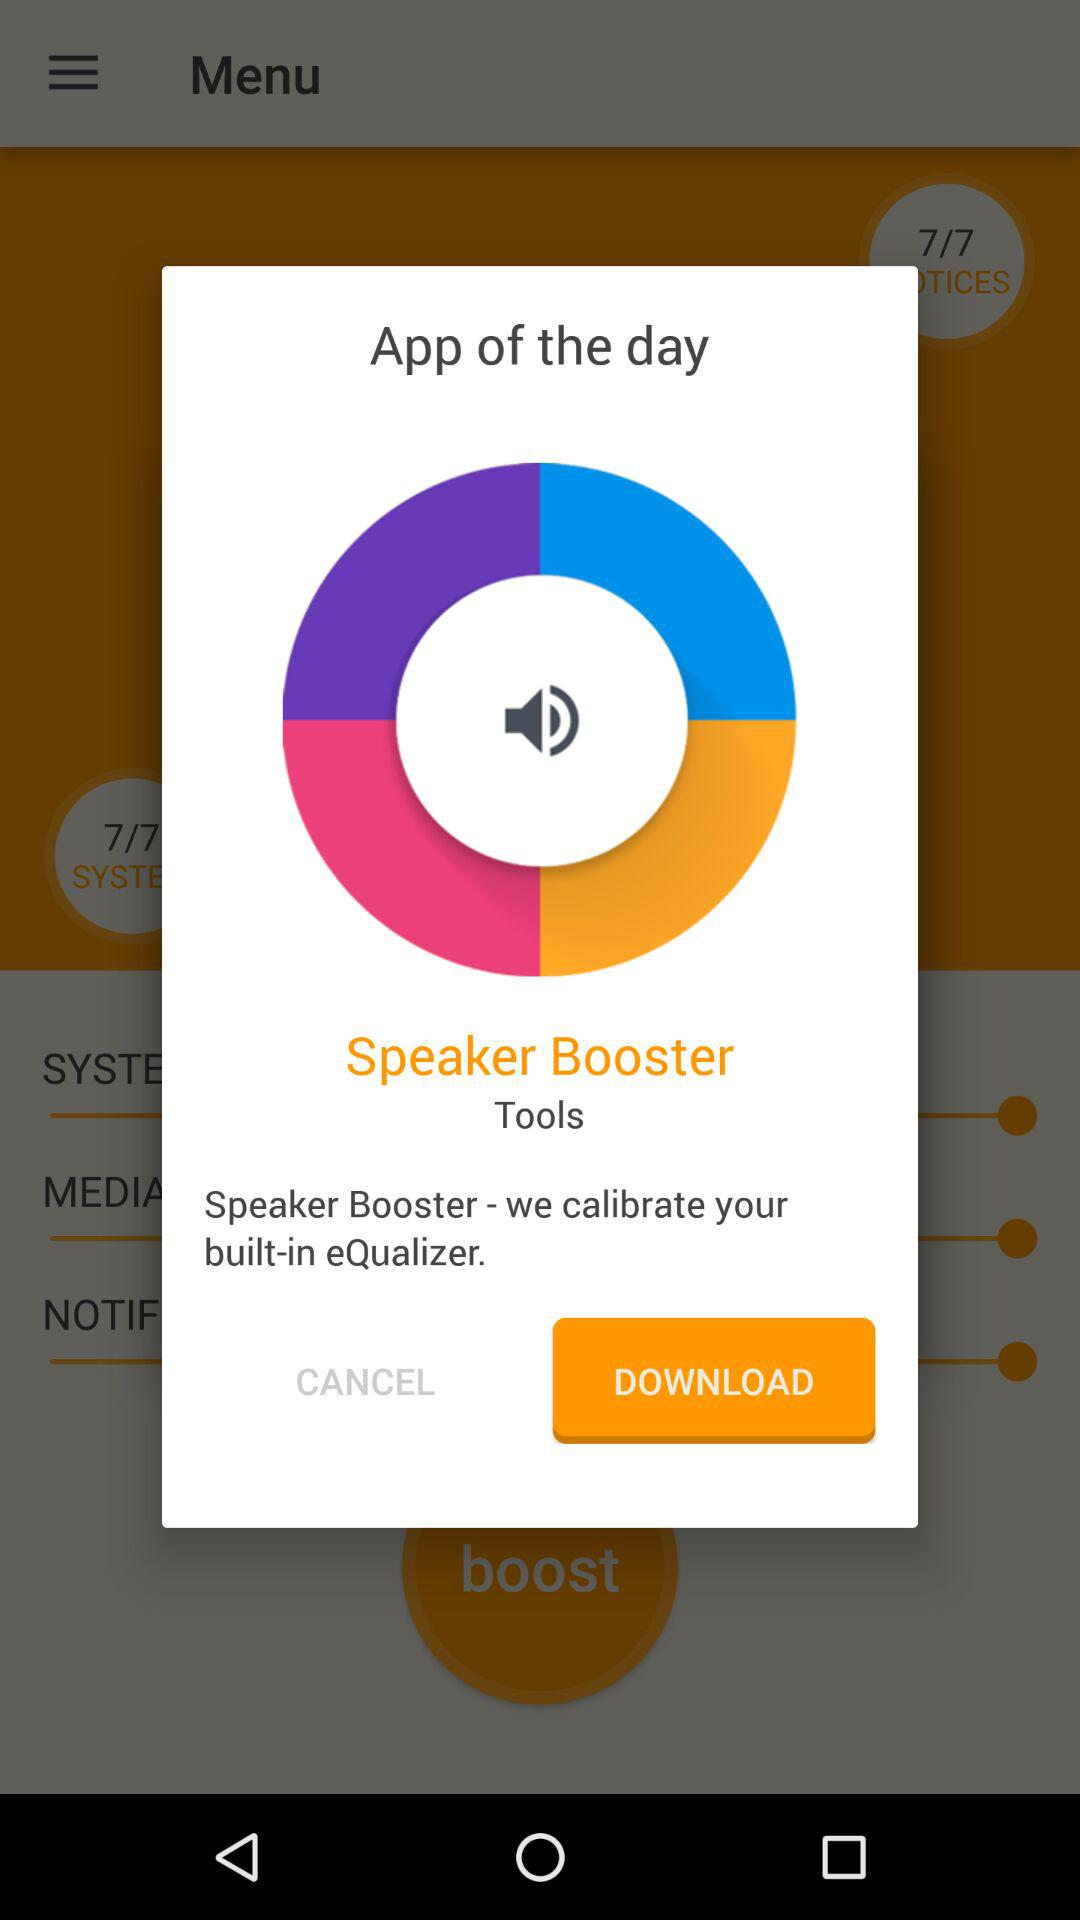What is the name of the application? The name of the application is "Speaker Booster". 